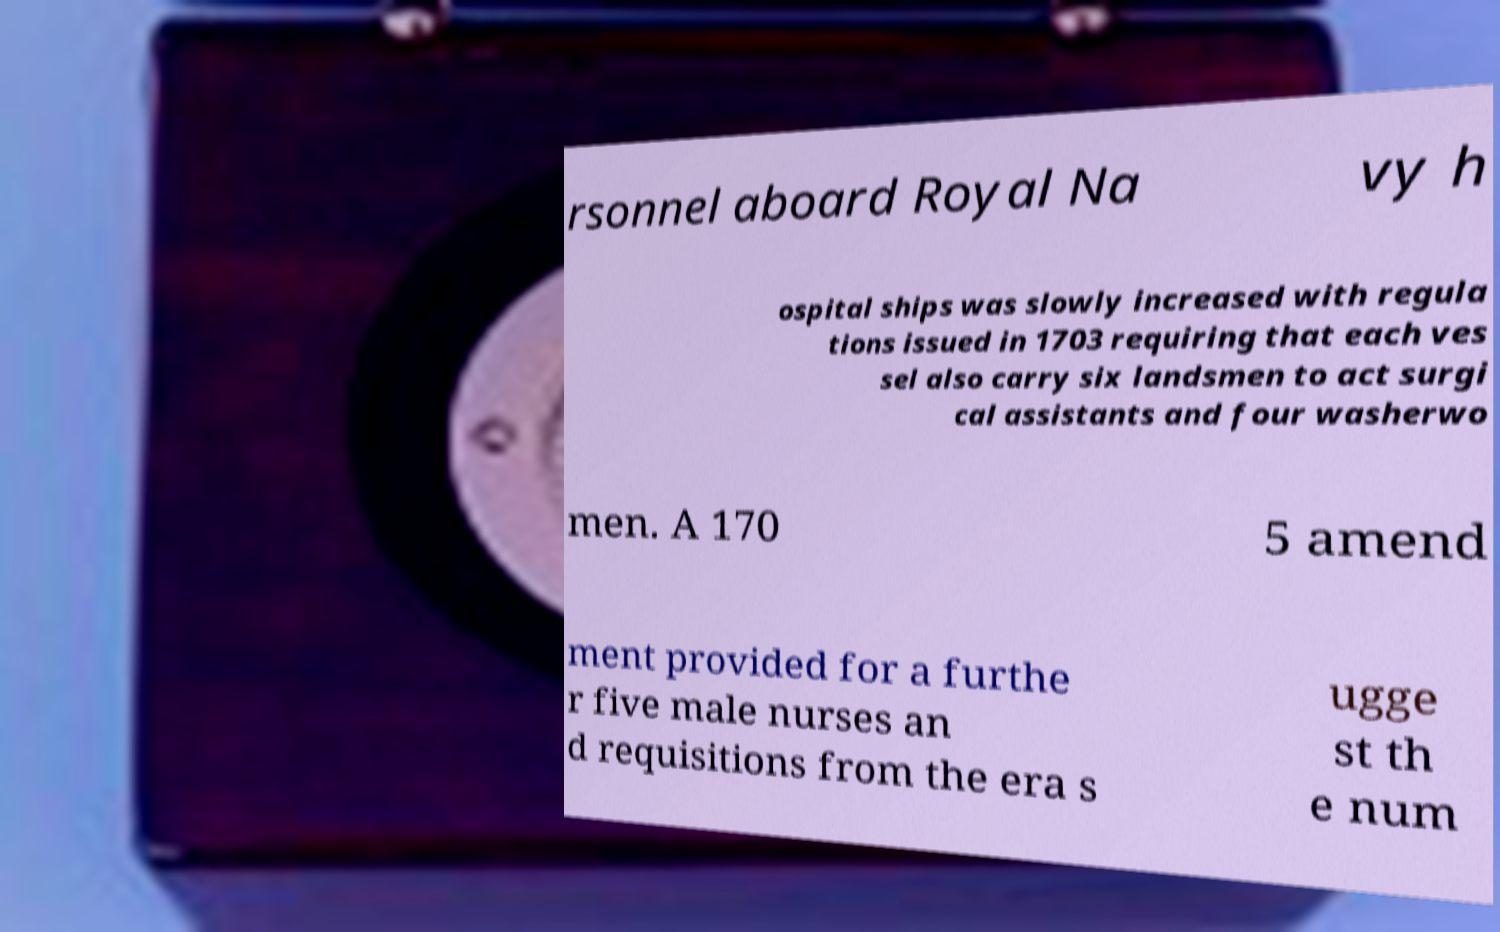Could you extract and type out the text from this image? rsonnel aboard Royal Na vy h ospital ships was slowly increased with regula tions issued in 1703 requiring that each ves sel also carry six landsmen to act surgi cal assistants and four washerwo men. A 170 5 amend ment provided for a furthe r five male nurses an d requisitions from the era s ugge st th e num 